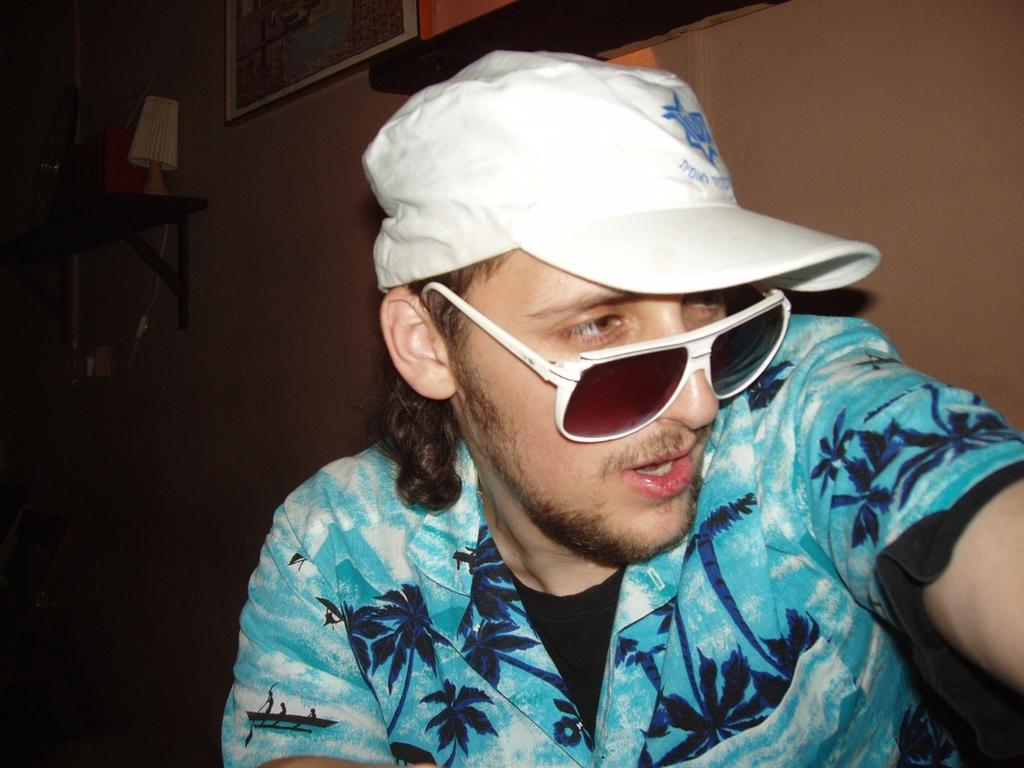What is the man in the image doing? The man is sitting in the image. Can you describe the man's appearance? The man is wearing glasses and a cap. What can be seen in the background of the image? There is a wall in the background of the image. What is on the wall? There are photo frames and a board on the wall. What is on the board? There are objects on the board. What type of snake can be seen crawling on the man's cap in the image? There is no snake present in the image; the man is wearing a cap, but no snake is visible. 